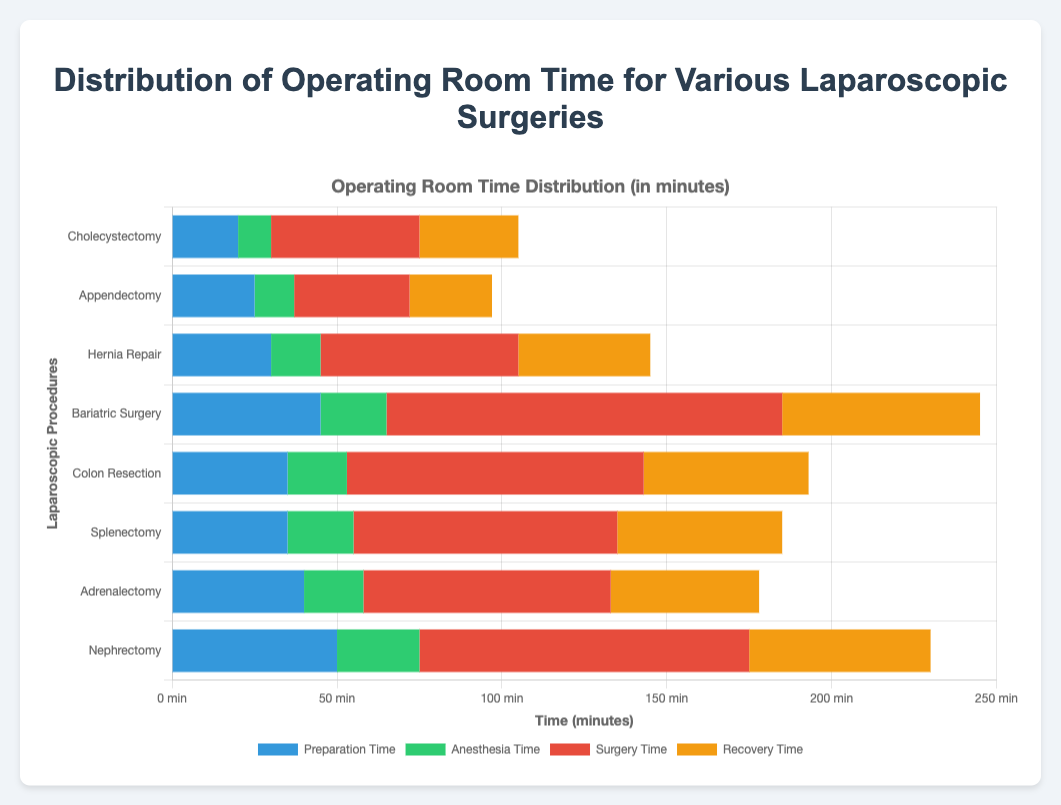What is the longest preoperative time for any procedure, and which procedure does it belong to? Scan through the preparation times and identify the longest one. The longest preparation time is 50 minutes for Nephrectomy.
Answer: Nephrectomy Which procedure has the shortest overall operating room time? To find the shortest overall time, sum up all time components (preparation, anesthesia, surgery, and recovery) for each procedure and identify the lowest total. Appendectomy has the shortest overall time of 97 minutes.
Answer: Appendectomy For Cholecystectomy, what is the total time from preparation to recovery? Add all time components (20 + 10 + 45 + 30) for Cholecystectomy. The total time is 105 minutes.
Answer: 105 minutes Which procedure has the longest surgery time, and how much longer is it compared to Hernia Repair? Identify the surgery times, highlighting the longest one and comparing it with Hernia Repair’s 60 minutes. Bariatric Surgery has the longest surgery time at 120 minutes, which is 60 minutes longer than Hernia Repair.
Answer: Bariatric Surgery, 60 minutes longer What is the average anesthesia time for all procedures? Sum all anesthesia times (10 + 12 + 15 + 20 + 18 + 20 + 18 + 25) and divide by the number of procedures (8). The total anesthetic time is 138 minutes, and the average is 138 / 8 = 17.25 minutes.
Answer: 17.25 minutes Between Bariatric Surgery and Colon Resection, which procedure has a shorter recovery time? Compare the recovery times of Bariatric Surgery (60 minutes) and Colon Resection (50 minutes). Colon Resection has a shorter recovery time.
Answer: Colon Resection How much more time is spent in anesthesia for Nephrectomy than for Appendectomy? Subtract the anesthesia time of Appendectomy from Nephrectomy (25 - 12). The difference is 13 minutes.
Answer: 13 minutes Which procedure has the highest preparation time and the lowest surgery time combination? Identify the procedure with the highest preparation time and lowest surgery time together by observing the individual times. Nephrectomy has the highest preparation time (50 minutes) combined with a surgery time of 100 minutes. Amongst all, Appendectomy has a relatively low surgery time of 35 minutes. However, combining the two should be avoided as they don't belong to a single procedure, hence do not combine them inaccurately.
Answer: This question is inherently incorrect due to cross-procedure combination What is the total operating room time for Splenectomy if preparation and recovery times are ignored? Add anesthesia and surgery times for Splenectomy (20 + 80). The total is 100 minutes excluding preparation and recovery.
Answer: 100 minutes Between Adrenalectomy and Colon Resection, which procedure takes longer for surgery, and by how many minutes? Compare the surgery times of Adrenalectomy (75 minutes) and Colon Resection (90 minutes). Colon Resection takes 15 minutes longer.
Answer: Colon Resection, 15 minutes longer 